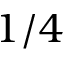<formula> <loc_0><loc_0><loc_500><loc_500>1 / 4</formula> 